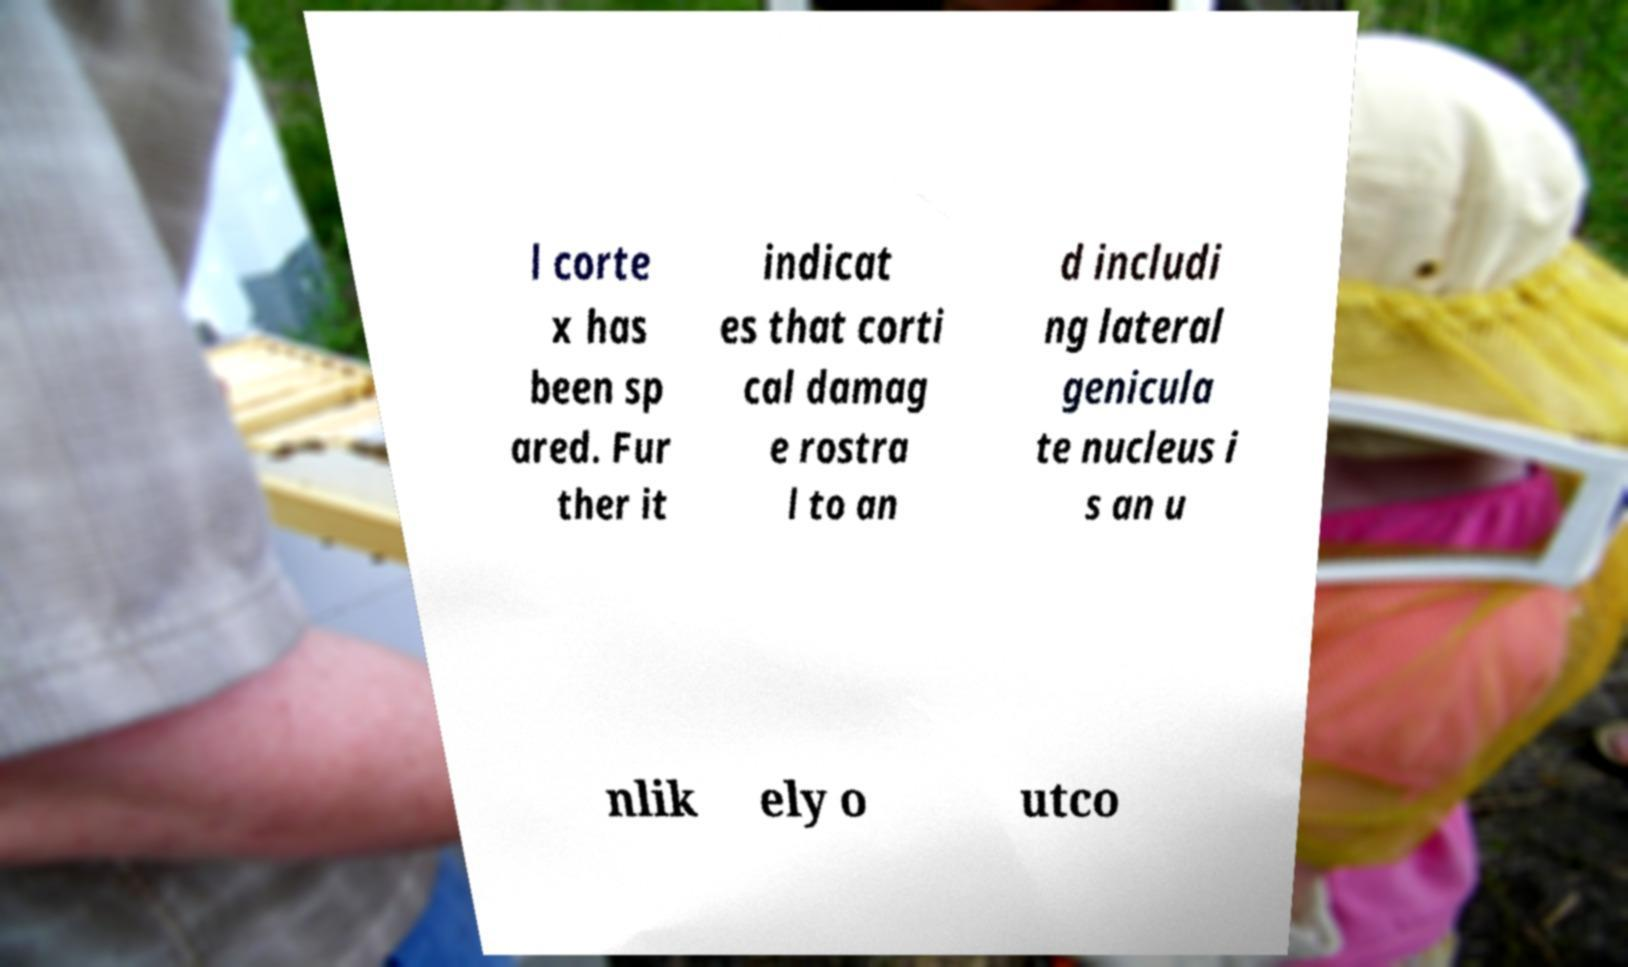For documentation purposes, I need the text within this image transcribed. Could you provide that? l corte x has been sp ared. Fur ther it indicat es that corti cal damag e rostra l to an d includi ng lateral genicula te nucleus i s an u nlik ely o utco 